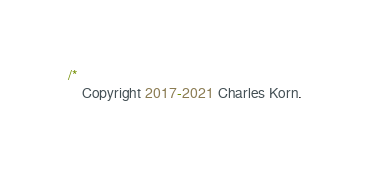<code> <loc_0><loc_0><loc_500><loc_500><_Kotlin_>/*
    Copyright 2017-2021 Charles Korn.
</code> 